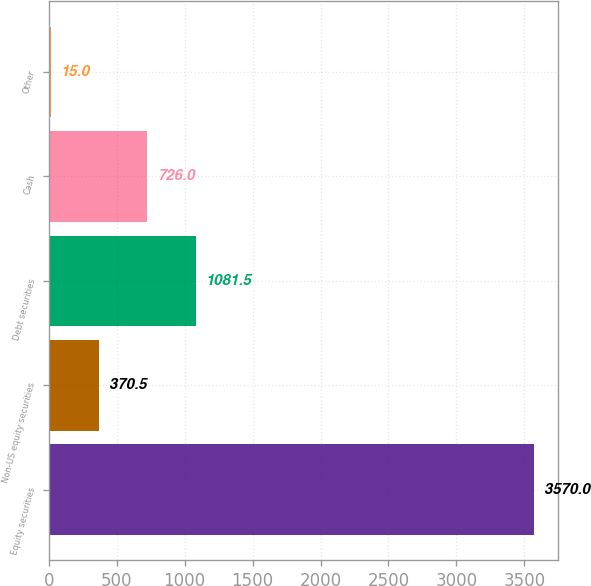<chart> <loc_0><loc_0><loc_500><loc_500><bar_chart><fcel>Equity securities<fcel>Non-US equity securities<fcel>Debt securities<fcel>Cash<fcel>Other<nl><fcel>3570<fcel>370.5<fcel>1081.5<fcel>726<fcel>15<nl></chart> 